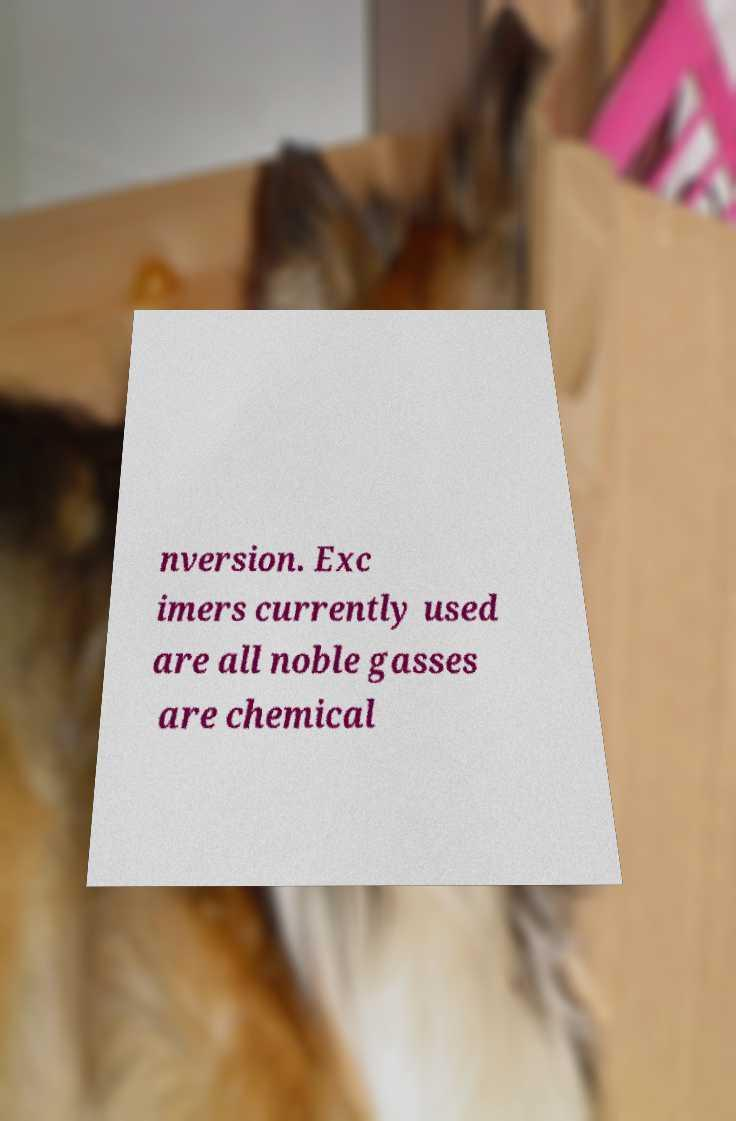Please identify and transcribe the text found in this image. nversion. Exc imers currently used are all noble gasses are chemical 